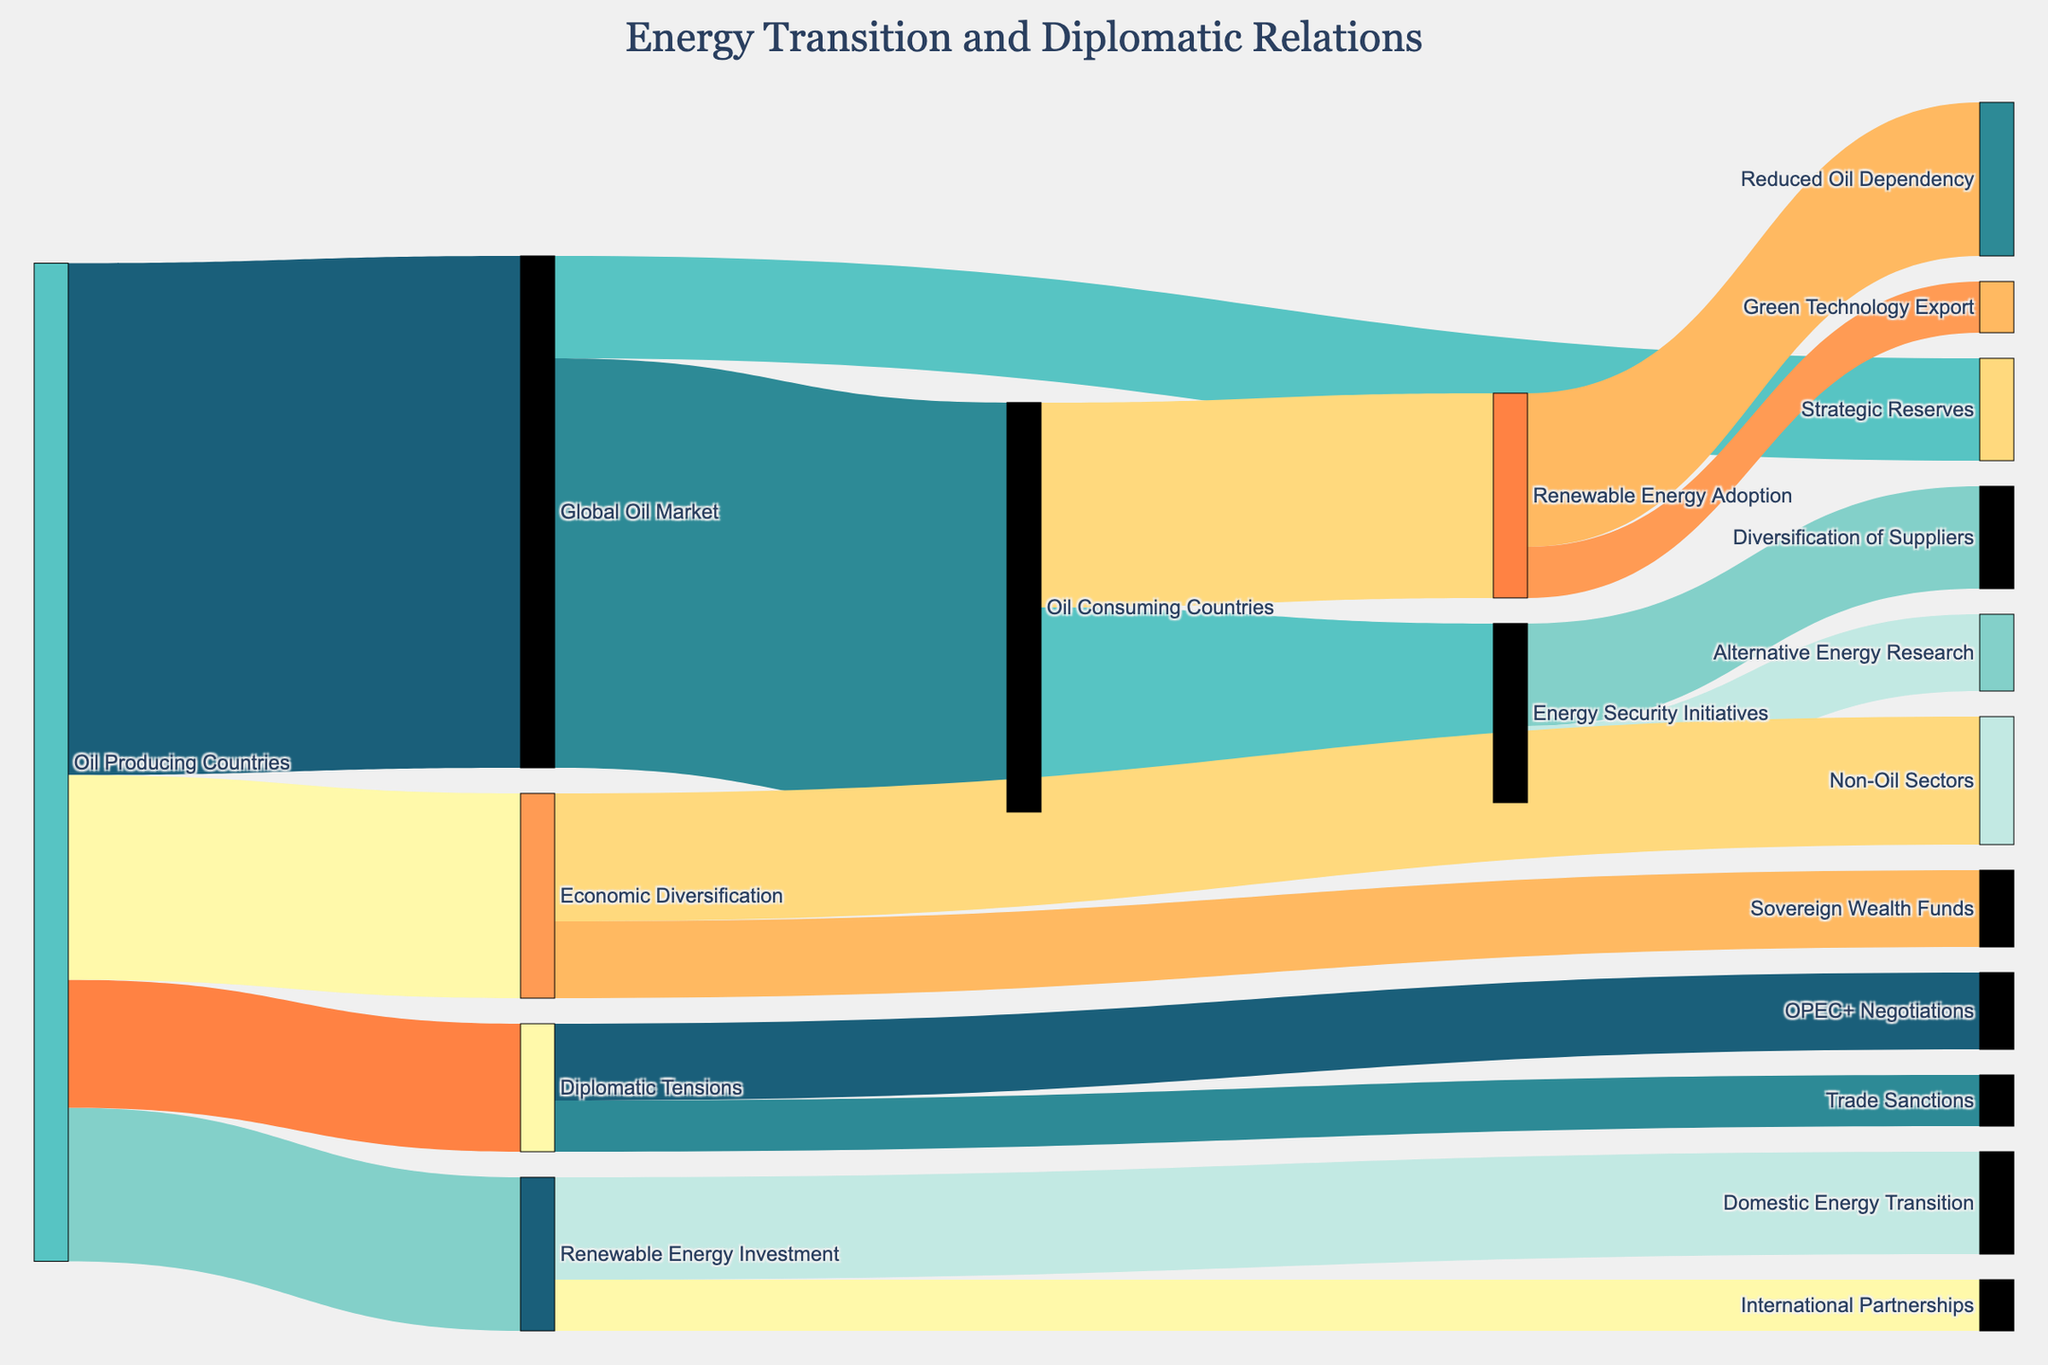How many categories or nodes are represented in this Sankey diagram? Count the distinct labels in both the source and target columns: Oil Producing Countries, Global Oil Market, Oil Consuming Countries, Strategic Reserves, Renewable Energy Investment, Domestic Energy Transition, International Partnerships, Renewable Energy Adoption, Reduced Oil Dependency, Green Technology Export, Diplomatic Tensions, OPEC+ Negotiations, Trade Sanctions, Energy Security Initiatives, Diversification of Suppliers, Alternative Energy Research, Economic Diversification, Non-Oil Sectors, Sovereign Wealth Funds.
Answer: 19 What is the total amount of oil flowing from the Global Oil Market to other categories? Add up the values flowing from the Global Oil Market: 80 (to Oil Consuming Countries) + 20 (to Strategic Reserves) = 100.
Answer: 100 Which category has the highest number of connections? Count the number of connections for each category and identify the highest: Oil Producing Countries (5), Global Oil Market (2), Oil Consuming Countries (3), Renewable Energy Investment (3), Diplomatic Tensions (2), Energy Security Initiatives (2), Economic Diversification (2).
Answer: Oil Producing Countries How does the amount of oil consumed by Oil Consuming Countries compare to the amount invested in Renewable Energy by Oil Producing Countries? Compare the values: Oil Consuming Countries receive 80 units of oil from the Global Oil Market; Oil Producing Countries invest 30 units in Renewable Energy.
Answer: Oil Consuming Countries consume more oil than what is invested in Renewable Energy by Oil Producing Countries What are the possible outcomes of Diplomatic Tensions according to the diagram? Identify the categories connected downstream from Diplomatic Tensions: Diplomatic Tensions lead to OPEC+ Negotiations (15) and Trade Sanctions (10).
Answer: OPEC+ Negotiations and Trade Sanctions How much oil is allocated to Strategic Reserves globally? Locate the value connecting Global Oil Market to Strategic Reserves: 20 units.
Answer: 20 How does the value flowing into Economic Diversification break down? Examine the flows into Economic Diversification: 25 units to Non-Oil Sectors and 15 units to Sovereign Wealth Funds.
Answer: 25 to Non-Oil Sectors and 15 to Sovereign Wealth Funds Calculate the net effect of Renewable Energy Adoption on Oil Dependency. Identify the flow from Renewable Energy Adoption to Reduced Oil Dependency: 30 units.
Answer: 30 What is the relationship between Economic Diversification and Non-Oil Sectors? Identify the connection and value from Economic Diversification to Non-Oil Sectors: 25 units.
Answer: Economic Diversification leads to Non-Oil Sectors with 25 units What are the initiatives taken by Oil Consuming Countries to enhance energy security? Identify the categories connected downstream from Energy Security Initiatives: Diversification of Suppliers (20) and Alternative Energy Research (15).
Answer: Diversification of Suppliers and Alternative Energy Research 